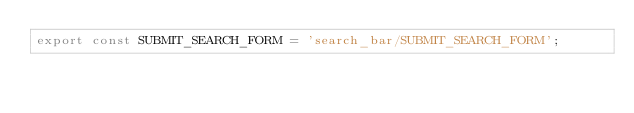Convert code to text. <code><loc_0><loc_0><loc_500><loc_500><_JavaScript_>export const SUBMIT_SEARCH_FORM = 'search_bar/SUBMIT_SEARCH_FORM';
</code> 